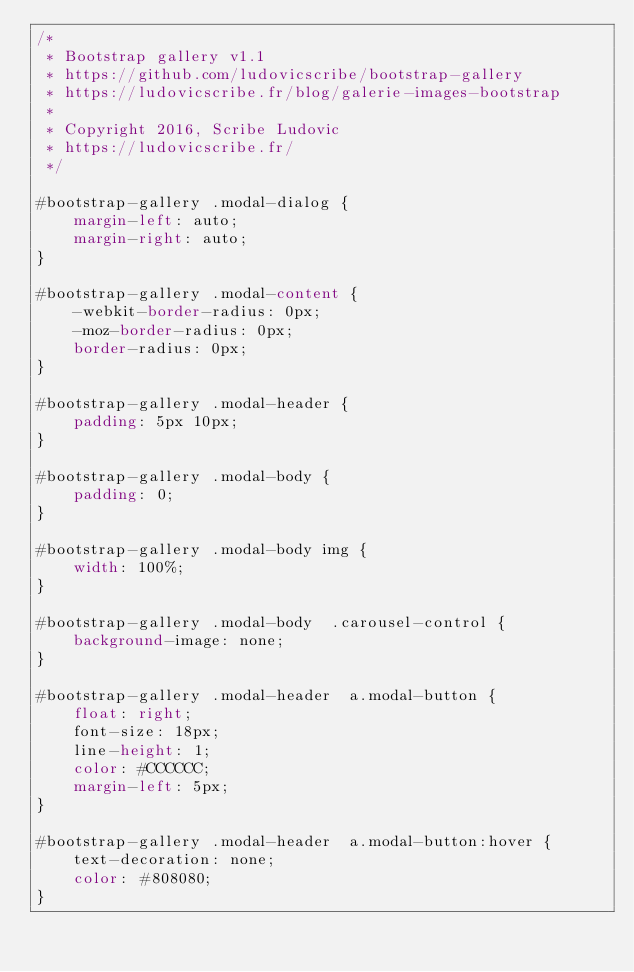<code> <loc_0><loc_0><loc_500><loc_500><_CSS_>/*
 * Bootstrap gallery v1.1
 * https://github.com/ludovicscribe/bootstrap-gallery
 * https://ludovicscribe.fr/blog/galerie-images-bootstrap
 *
 * Copyright 2016, Scribe Ludovic
 * https://ludovicscribe.fr/
 */

#bootstrap-gallery .modal-dialog {
	margin-left: auto;
	margin-right: auto;
}

#bootstrap-gallery .modal-content {
	-webkit-border-radius: 0px;
	-moz-border-radius: 0px;
	border-radius: 0px;
}

#bootstrap-gallery .modal-header {
	padding: 5px 10px;
}

#bootstrap-gallery .modal-body {
	padding: 0;
}

#bootstrap-gallery .modal-body img {
	width: 100%;
}

#bootstrap-gallery .modal-body  .carousel-control {
	background-image: none;
}

#bootstrap-gallery .modal-header  a.modal-button {
	float: right;
	font-size: 18px;
	line-height: 1;
	color: #CCCCCC;
	margin-left: 5px;
}

#bootstrap-gallery .modal-header  a.modal-button:hover {
	text-decoration: none;
	color: #808080;
}</code> 